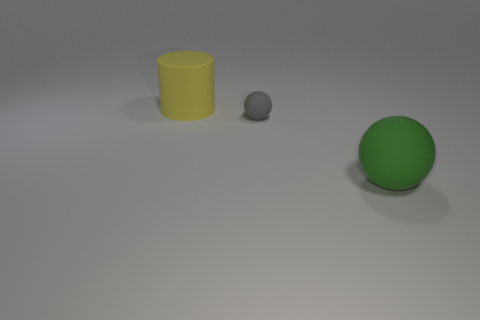Add 3 balls. How many objects exist? 6 Subtract all cylinders. How many objects are left? 2 Add 1 large yellow rubber cylinders. How many large yellow rubber cylinders are left? 2 Add 3 big yellow things. How many big yellow things exist? 4 Subtract 0 green blocks. How many objects are left? 3 Subtract all small purple metal cylinders. Subtract all large balls. How many objects are left? 2 